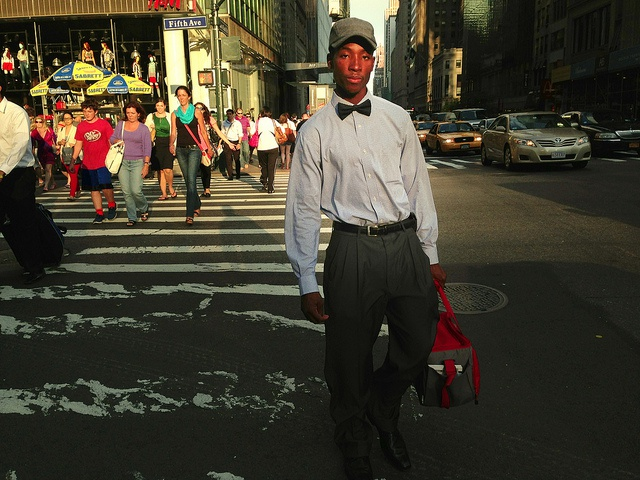Describe the objects in this image and their specific colors. I can see people in tan, black, darkgray, and lightgray tones, people in tan, black, khaki, and gray tones, handbag in tan, black, maroon, and gray tones, car in tan, black, gray, and darkgreen tones, and suitcase in tan, black, maroon, and gray tones in this image. 